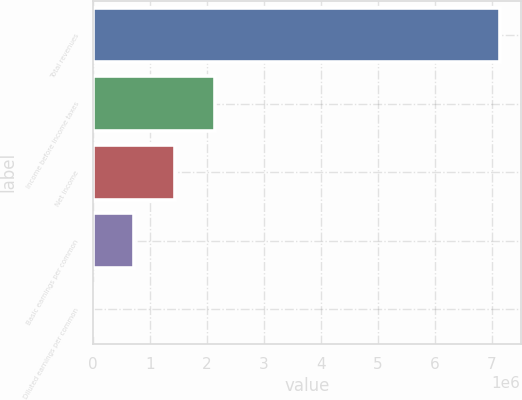<chart> <loc_0><loc_0><loc_500><loc_500><bar_chart><fcel>Total revenues<fcel>Income before income taxes<fcel>Net income<fcel>Basic earnings per common<fcel>Diluted earnings per common<nl><fcel>7.14817e+06<fcel>2.14445e+06<fcel>1.42963e+06<fcel>714818<fcel>1.09<nl></chart> 